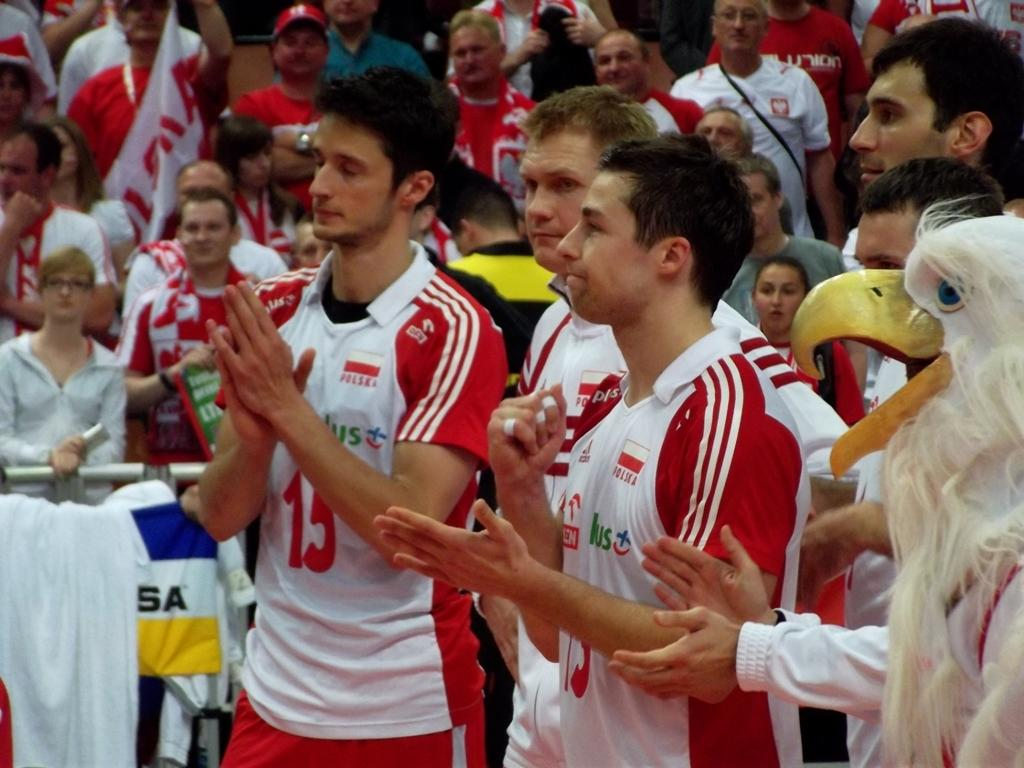<image>
Offer a succinct explanation of the picture presented. the number 13 that is on a jersey 